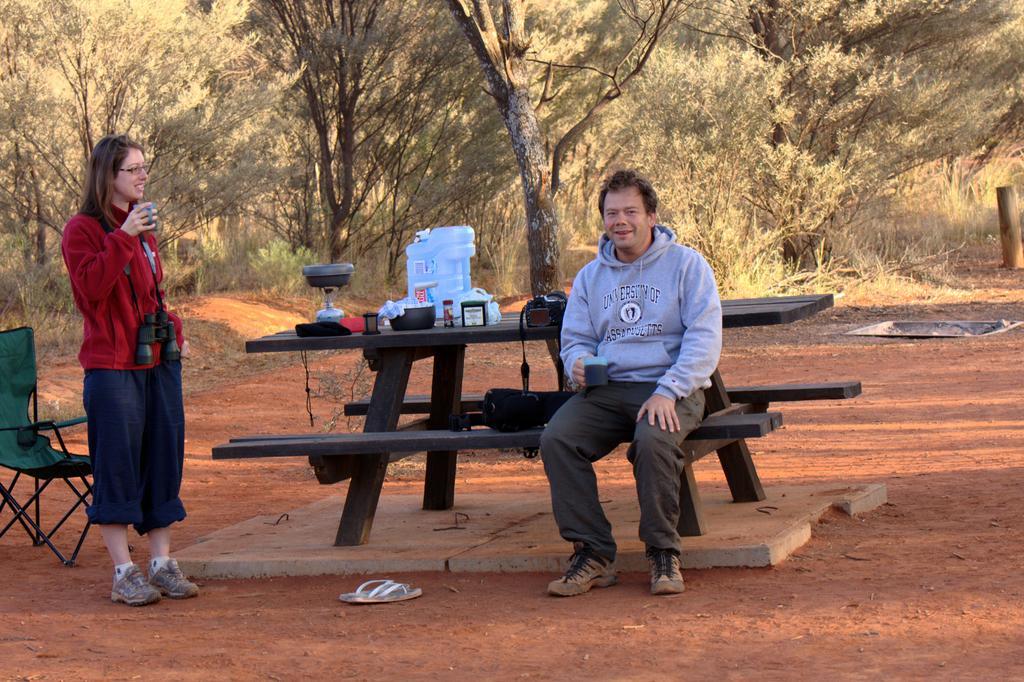Describe this image in one or two sentences. In this image there are two persons one is sitting and smiling and other one is standing and smiling. There is a bowl, camera, bottle on the bench, at the back there are trees and at the left there is a chair, at the bottom there is a footwear. 